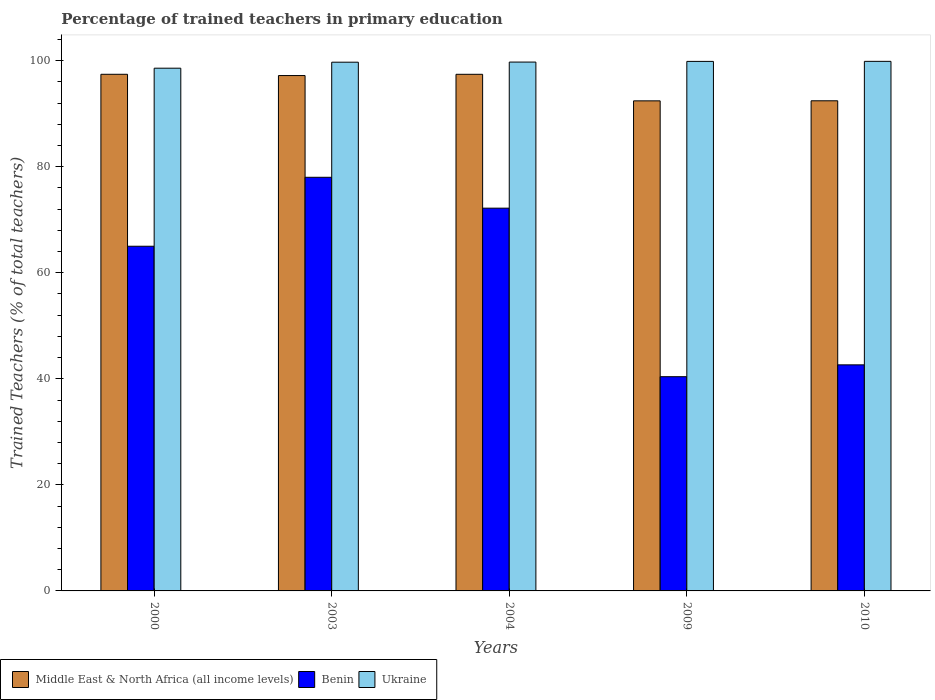How many different coloured bars are there?
Your response must be concise. 3. How many groups of bars are there?
Give a very brief answer. 5. Are the number of bars per tick equal to the number of legend labels?
Keep it short and to the point. Yes. How many bars are there on the 4th tick from the left?
Your answer should be compact. 3. In how many cases, is the number of bars for a given year not equal to the number of legend labels?
Provide a succinct answer. 0. What is the percentage of trained teachers in Middle East & North Africa (all income levels) in 2003?
Keep it short and to the point. 97.18. Across all years, what is the maximum percentage of trained teachers in Ukraine?
Give a very brief answer. 99.86. Across all years, what is the minimum percentage of trained teachers in Middle East & North Africa (all income levels)?
Offer a terse response. 92.41. In which year was the percentage of trained teachers in Benin maximum?
Provide a succinct answer. 2003. What is the total percentage of trained teachers in Ukraine in the graph?
Offer a terse response. 497.72. What is the difference between the percentage of trained teachers in Middle East & North Africa (all income levels) in 2004 and that in 2010?
Your response must be concise. 4.99. What is the difference between the percentage of trained teachers in Benin in 2010 and the percentage of trained teachers in Ukraine in 2003?
Make the answer very short. -57.07. What is the average percentage of trained teachers in Middle East & North Africa (all income levels) per year?
Provide a succinct answer. 95.37. In the year 2004, what is the difference between the percentage of trained teachers in Ukraine and percentage of trained teachers in Benin?
Your answer should be compact. 27.55. What is the ratio of the percentage of trained teachers in Ukraine in 2009 to that in 2010?
Offer a terse response. 1. Is the percentage of trained teachers in Ukraine in 2000 less than that in 2009?
Provide a succinct answer. Yes. What is the difference between the highest and the second highest percentage of trained teachers in Benin?
Make the answer very short. 5.82. What is the difference between the highest and the lowest percentage of trained teachers in Middle East & North Africa (all income levels)?
Your answer should be compact. 5.01. Is the sum of the percentage of trained teachers in Middle East & North Africa (all income levels) in 2004 and 2009 greater than the maximum percentage of trained teachers in Benin across all years?
Offer a terse response. Yes. What does the 1st bar from the left in 2003 represents?
Provide a short and direct response. Middle East & North Africa (all income levels). What does the 1st bar from the right in 2000 represents?
Provide a succinct answer. Ukraine. Are all the bars in the graph horizontal?
Provide a short and direct response. No. Are the values on the major ticks of Y-axis written in scientific E-notation?
Provide a short and direct response. No. Does the graph contain any zero values?
Provide a succinct answer. No. Where does the legend appear in the graph?
Your answer should be compact. Bottom left. How many legend labels are there?
Offer a very short reply. 3. How are the legend labels stacked?
Ensure brevity in your answer.  Horizontal. What is the title of the graph?
Your answer should be compact. Percentage of trained teachers in primary education. Does "Tuvalu" appear as one of the legend labels in the graph?
Offer a very short reply. No. What is the label or title of the Y-axis?
Offer a very short reply. Trained Teachers (% of total teachers). What is the Trained Teachers (% of total teachers) in Middle East & North Africa (all income levels) in 2000?
Offer a terse response. 97.42. What is the Trained Teachers (% of total teachers) of Benin in 2000?
Your response must be concise. 65. What is the Trained Teachers (% of total teachers) of Ukraine in 2000?
Give a very brief answer. 98.57. What is the Trained Teachers (% of total teachers) of Middle East & North Africa (all income levels) in 2003?
Provide a succinct answer. 97.18. What is the Trained Teachers (% of total teachers) of Benin in 2003?
Offer a terse response. 78. What is the Trained Teachers (% of total teachers) of Ukraine in 2003?
Offer a very short reply. 99.7. What is the Trained Teachers (% of total teachers) of Middle East & North Africa (all income levels) in 2004?
Your answer should be compact. 97.42. What is the Trained Teachers (% of total teachers) in Benin in 2004?
Make the answer very short. 72.18. What is the Trained Teachers (% of total teachers) in Ukraine in 2004?
Provide a succinct answer. 99.73. What is the Trained Teachers (% of total teachers) in Middle East & North Africa (all income levels) in 2009?
Make the answer very short. 92.41. What is the Trained Teachers (% of total teachers) in Benin in 2009?
Provide a succinct answer. 40.4. What is the Trained Teachers (% of total teachers) in Ukraine in 2009?
Keep it short and to the point. 99.86. What is the Trained Teachers (% of total teachers) in Middle East & North Africa (all income levels) in 2010?
Provide a succinct answer. 92.43. What is the Trained Teachers (% of total teachers) of Benin in 2010?
Offer a very short reply. 42.63. What is the Trained Teachers (% of total teachers) in Ukraine in 2010?
Keep it short and to the point. 99.86. Across all years, what is the maximum Trained Teachers (% of total teachers) in Middle East & North Africa (all income levels)?
Offer a very short reply. 97.42. Across all years, what is the maximum Trained Teachers (% of total teachers) in Benin?
Provide a short and direct response. 78. Across all years, what is the maximum Trained Teachers (% of total teachers) of Ukraine?
Provide a succinct answer. 99.86. Across all years, what is the minimum Trained Teachers (% of total teachers) in Middle East & North Africa (all income levels)?
Provide a succinct answer. 92.41. Across all years, what is the minimum Trained Teachers (% of total teachers) of Benin?
Your answer should be compact. 40.4. Across all years, what is the minimum Trained Teachers (% of total teachers) of Ukraine?
Your answer should be compact. 98.57. What is the total Trained Teachers (% of total teachers) of Middle East & North Africa (all income levels) in the graph?
Your answer should be compact. 476.87. What is the total Trained Teachers (% of total teachers) in Benin in the graph?
Your answer should be very brief. 298.2. What is the total Trained Teachers (% of total teachers) of Ukraine in the graph?
Your answer should be compact. 497.72. What is the difference between the Trained Teachers (% of total teachers) of Middle East & North Africa (all income levels) in 2000 and that in 2003?
Offer a terse response. 0.24. What is the difference between the Trained Teachers (% of total teachers) of Benin in 2000 and that in 2003?
Offer a terse response. -13. What is the difference between the Trained Teachers (% of total teachers) of Ukraine in 2000 and that in 2003?
Ensure brevity in your answer.  -1.13. What is the difference between the Trained Teachers (% of total teachers) of Middle East & North Africa (all income levels) in 2000 and that in 2004?
Your answer should be compact. 0. What is the difference between the Trained Teachers (% of total teachers) in Benin in 2000 and that in 2004?
Provide a succinct answer. -7.18. What is the difference between the Trained Teachers (% of total teachers) of Ukraine in 2000 and that in 2004?
Ensure brevity in your answer.  -1.15. What is the difference between the Trained Teachers (% of total teachers) of Middle East & North Africa (all income levels) in 2000 and that in 2009?
Provide a short and direct response. 5.01. What is the difference between the Trained Teachers (% of total teachers) in Benin in 2000 and that in 2009?
Offer a very short reply. 24.6. What is the difference between the Trained Teachers (% of total teachers) of Ukraine in 2000 and that in 2009?
Keep it short and to the point. -1.28. What is the difference between the Trained Teachers (% of total teachers) of Middle East & North Africa (all income levels) in 2000 and that in 2010?
Offer a terse response. 4.99. What is the difference between the Trained Teachers (% of total teachers) in Benin in 2000 and that in 2010?
Provide a short and direct response. 22.37. What is the difference between the Trained Teachers (% of total teachers) in Ukraine in 2000 and that in 2010?
Keep it short and to the point. -1.29. What is the difference between the Trained Teachers (% of total teachers) of Middle East & North Africa (all income levels) in 2003 and that in 2004?
Keep it short and to the point. -0.24. What is the difference between the Trained Teachers (% of total teachers) of Benin in 2003 and that in 2004?
Ensure brevity in your answer.  5.82. What is the difference between the Trained Teachers (% of total teachers) of Ukraine in 2003 and that in 2004?
Offer a terse response. -0.02. What is the difference between the Trained Teachers (% of total teachers) of Middle East & North Africa (all income levels) in 2003 and that in 2009?
Your response must be concise. 4.77. What is the difference between the Trained Teachers (% of total teachers) of Benin in 2003 and that in 2009?
Provide a succinct answer. 37.6. What is the difference between the Trained Teachers (% of total teachers) of Ukraine in 2003 and that in 2009?
Offer a very short reply. -0.15. What is the difference between the Trained Teachers (% of total teachers) of Middle East & North Africa (all income levels) in 2003 and that in 2010?
Your answer should be very brief. 4.76. What is the difference between the Trained Teachers (% of total teachers) in Benin in 2003 and that in 2010?
Offer a very short reply. 35.37. What is the difference between the Trained Teachers (% of total teachers) of Ukraine in 2003 and that in 2010?
Keep it short and to the point. -0.16. What is the difference between the Trained Teachers (% of total teachers) of Middle East & North Africa (all income levels) in 2004 and that in 2009?
Your answer should be very brief. 5.01. What is the difference between the Trained Teachers (% of total teachers) in Benin in 2004 and that in 2009?
Give a very brief answer. 31.78. What is the difference between the Trained Teachers (% of total teachers) of Ukraine in 2004 and that in 2009?
Keep it short and to the point. -0.13. What is the difference between the Trained Teachers (% of total teachers) of Middle East & North Africa (all income levels) in 2004 and that in 2010?
Make the answer very short. 4.99. What is the difference between the Trained Teachers (% of total teachers) in Benin in 2004 and that in 2010?
Offer a terse response. 29.55. What is the difference between the Trained Teachers (% of total teachers) in Ukraine in 2004 and that in 2010?
Make the answer very short. -0.14. What is the difference between the Trained Teachers (% of total teachers) in Middle East & North Africa (all income levels) in 2009 and that in 2010?
Ensure brevity in your answer.  -0.01. What is the difference between the Trained Teachers (% of total teachers) of Benin in 2009 and that in 2010?
Make the answer very short. -2.23. What is the difference between the Trained Teachers (% of total teachers) of Ukraine in 2009 and that in 2010?
Give a very brief answer. -0.01. What is the difference between the Trained Teachers (% of total teachers) in Middle East & North Africa (all income levels) in 2000 and the Trained Teachers (% of total teachers) in Benin in 2003?
Your answer should be very brief. 19.42. What is the difference between the Trained Teachers (% of total teachers) of Middle East & North Africa (all income levels) in 2000 and the Trained Teachers (% of total teachers) of Ukraine in 2003?
Offer a very short reply. -2.28. What is the difference between the Trained Teachers (% of total teachers) of Benin in 2000 and the Trained Teachers (% of total teachers) of Ukraine in 2003?
Give a very brief answer. -34.71. What is the difference between the Trained Teachers (% of total teachers) in Middle East & North Africa (all income levels) in 2000 and the Trained Teachers (% of total teachers) in Benin in 2004?
Your answer should be very brief. 25.25. What is the difference between the Trained Teachers (% of total teachers) in Middle East & North Africa (all income levels) in 2000 and the Trained Teachers (% of total teachers) in Ukraine in 2004?
Keep it short and to the point. -2.31. What is the difference between the Trained Teachers (% of total teachers) in Benin in 2000 and the Trained Teachers (% of total teachers) in Ukraine in 2004?
Your answer should be compact. -34.73. What is the difference between the Trained Teachers (% of total teachers) of Middle East & North Africa (all income levels) in 2000 and the Trained Teachers (% of total teachers) of Benin in 2009?
Ensure brevity in your answer.  57.02. What is the difference between the Trained Teachers (% of total teachers) of Middle East & North Africa (all income levels) in 2000 and the Trained Teachers (% of total teachers) of Ukraine in 2009?
Give a very brief answer. -2.43. What is the difference between the Trained Teachers (% of total teachers) of Benin in 2000 and the Trained Teachers (% of total teachers) of Ukraine in 2009?
Provide a short and direct response. -34.86. What is the difference between the Trained Teachers (% of total teachers) in Middle East & North Africa (all income levels) in 2000 and the Trained Teachers (% of total teachers) in Benin in 2010?
Provide a succinct answer. 54.79. What is the difference between the Trained Teachers (% of total teachers) of Middle East & North Africa (all income levels) in 2000 and the Trained Teachers (% of total teachers) of Ukraine in 2010?
Provide a succinct answer. -2.44. What is the difference between the Trained Teachers (% of total teachers) of Benin in 2000 and the Trained Teachers (% of total teachers) of Ukraine in 2010?
Ensure brevity in your answer.  -34.87. What is the difference between the Trained Teachers (% of total teachers) in Middle East & North Africa (all income levels) in 2003 and the Trained Teachers (% of total teachers) in Benin in 2004?
Ensure brevity in your answer.  25.01. What is the difference between the Trained Teachers (% of total teachers) in Middle East & North Africa (all income levels) in 2003 and the Trained Teachers (% of total teachers) in Ukraine in 2004?
Provide a succinct answer. -2.54. What is the difference between the Trained Teachers (% of total teachers) in Benin in 2003 and the Trained Teachers (% of total teachers) in Ukraine in 2004?
Make the answer very short. -21.73. What is the difference between the Trained Teachers (% of total teachers) in Middle East & North Africa (all income levels) in 2003 and the Trained Teachers (% of total teachers) in Benin in 2009?
Your answer should be compact. 56.79. What is the difference between the Trained Teachers (% of total teachers) in Middle East & North Africa (all income levels) in 2003 and the Trained Teachers (% of total teachers) in Ukraine in 2009?
Make the answer very short. -2.67. What is the difference between the Trained Teachers (% of total teachers) in Benin in 2003 and the Trained Teachers (% of total teachers) in Ukraine in 2009?
Your answer should be compact. -21.86. What is the difference between the Trained Teachers (% of total teachers) in Middle East & North Africa (all income levels) in 2003 and the Trained Teachers (% of total teachers) in Benin in 2010?
Offer a terse response. 54.55. What is the difference between the Trained Teachers (% of total teachers) of Middle East & North Africa (all income levels) in 2003 and the Trained Teachers (% of total teachers) of Ukraine in 2010?
Give a very brief answer. -2.68. What is the difference between the Trained Teachers (% of total teachers) of Benin in 2003 and the Trained Teachers (% of total teachers) of Ukraine in 2010?
Provide a succinct answer. -21.86. What is the difference between the Trained Teachers (% of total teachers) in Middle East & North Africa (all income levels) in 2004 and the Trained Teachers (% of total teachers) in Benin in 2009?
Keep it short and to the point. 57.02. What is the difference between the Trained Teachers (% of total teachers) in Middle East & North Africa (all income levels) in 2004 and the Trained Teachers (% of total teachers) in Ukraine in 2009?
Ensure brevity in your answer.  -2.44. What is the difference between the Trained Teachers (% of total teachers) of Benin in 2004 and the Trained Teachers (% of total teachers) of Ukraine in 2009?
Provide a succinct answer. -27.68. What is the difference between the Trained Teachers (% of total teachers) in Middle East & North Africa (all income levels) in 2004 and the Trained Teachers (% of total teachers) in Benin in 2010?
Provide a succinct answer. 54.79. What is the difference between the Trained Teachers (% of total teachers) of Middle East & North Africa (all income levels) in 2004 and the Trained Teachers (% of total teachers) of Ukraine in 2010?
Keep it short and to the point. -2.44. What is the difference between the Trained Teachers (% of total teachers) of Benin in 2004 and the Trained Teachers (% of total teachers) of Ukraine in 2010?
Keep it short and to the point. -27.69. What is the difference between the Trained Teachers (% of total teachers) of Middle East & North Africa (all income levels) in 2009 and the Trained Teachers (% of total teachers) of Benin in 2010?
Provide a short and direct response. 49.78. What is the difference between the Trained Teachers (% of total teachers) of Middle East & North Africa (all income levels) in 2009 and the Trained Teachers (% of total teachers) of Ukraine in 2010?
Your answer should be very brief. -7.45. What is the difference between the Trained Teachers (% of total teachers) in Benin in 2009 and the Trained Teachers (% of total teachers) in Ukraine in 2010?
Your answer should be compact. -59.46. What is the average Trained Teachers (% of total teachers) of Middle East & North Africa (all income levels) per year?
Offer a very short reply. 95.37. What is the average Trained Teachers (% of total teachers) in Benin per year?
Keep it short and to the point. 59.64. What is the average Trained Teachers (% of total teachers) of Ukraine per year?
Make the answer very short. 99.54. In the year 2000, what is the difference between the Trained Teachers (% of total teachers) of Middle East & North Africa (all income levels) and Trained Teachers (% of total teachers) of Benin?
Your answer should be compact. 32.42. In the year 2000, what is the difference between the Trained Teachers (% of total teachers) of Middle East & North Africa (all income levels) and Trained Teachers (% of total teachers) of Ukraine?
Give a very brief answer. -1.15. In the year 2000, what is the difference between the Trained Teachers (% of total teachers) of Benin and Trained Teachers (% of total teachers) of Ukraine?
Offer a very short reply. -33.58. In the year 2003, what is the difference between the Trained Teachers (% of total teachers) of Middle East & North Africa (all income levels) and Trained Teachers (% of total teachers) of Benin?
Provide a short and direct response. 19.19. In the year 2003, what is the difference between the Trained Teachers (% of total teachers) of Middle East & North Africa (all income levels) and Trained Teachers (% of total teachers) of Ukraine?
Ensure brevity in your answer.  -2.52. In the year 2003, what is the difference between the Trained Teachers (% of total teachers) of Benin and Trained Teachers (% of total teachers) of Ukraine?
Offer a terse response. -21.7. In the year 2004, what is the difference between the Trained Teachers (% of total teachers) in Middle East & North Africa (all income levels) and Trained Teachers (% of total teachers) in Benin?
Your answer should be very brief. 25.24. In the year 2004, what is the difference between the Trained Teachers (% of total teachers) in Middle East & North Africa (all income levels) and Trained Teachers (% of total teachers) in Ukraine?
Offer a terse response. -2.31. In the year 2004, what is the difference between the Trained Teachers (% of total teachers) in Benin and Trained Teachers (% of total teachers) in Ukraine?
Offer a terse response. -27.55. In the year 2009, what is the difference between the Trained Teachers (% of total teachers) in Middle East & North Africa (all income levels) and Trained Teachers (% of total teachers) in Benin?
Your response must be concise. 52.02. In the year 2009, what is the difference between the Trained Teachers (% of total teachers) of Middle East & North Africa (all income levels) and Trained Teachers (% of total teachers) of Ukraine?
Ensure brevity in your answer.  -7.44. In the year 2009, what is the difference between the Trained Teachers (% of total teachers) in Benin and Trained Teachers (% of total teachers) in Ukraine?
Your answer should be compact. -59.46. In the year 2010, what is the difference between the Trained Teachers (% of total teachers) of Middle East & North Africa (all income levels) and Trained Teachers (% of total teachers) of Benin?
Make the answer very short. 49.8. In the year 2010, what is the difference between the Trained Teachers (% of total teachers) of Middle East & North Africa (all income levels) and Trained Teachers (% of total teachers) of Ukraine?
Make the answer very short. -7.44. In the year 2010, what is the difference between the Trained Teachers (% of total teachers) of Benin and Trained Teachers (% of total teachers) of Ukraine?
Make the answer very short. -57.23. What is the ratio of the Trained Teachers (% of total teachers) in Middle East & North Africa (all income levels) in 2000 to that in 2003?
Your answer should be compact. 1. What is the ratio of the Trained Teachers (% of total teachers) of Ukraine in 2000 to that in 2003?
Your response must be concise. 0.99. What is the ratio of the Trained Teachers (% of total teachers) of Benin in 2000 to that in 2004?
Give a very brief answer. 0.9. What is the ratio of the Trained Teachers (% of total teachers) in Ukraine in 2000 to that in 2004?
Give a very brief answer. 0.99. What is the ratio of the Trained Teachers (% of total teachers) in Middle East & North Africa (all income levels) in 2000 to that in 2009?
Provide a short and direct response. 1.05. What is the ratio of the Trained Teachers (% of total teachers) of Benin in 2000 to that in 2009?
Your answer should be very brief. 1.61. What is the ratio of the Trained Teachers (% of total teachers) in Ukraine in 2000 to that in 2009?
Offer a terse response. 0.99. What is the ratio of the Trained Teachers (% of total teachers) of Middle East & North Africa (all income levels) in 2000 to that in 2010?
Ensure brevity in your answer.  1.05. What is the ratio of the Trained Teachers (% of total teachers) of Benin in 2000 to that in 2010?
Your response must be concise. 1.52. What is the ratio of the Trained Teachers (% of total teachers) of Ukraine in 2000 to that in 2010?
Keep it short and to the point. 0.99. What is the ratio of the Trained Teachers (% of total teachers) in Benin in 2003 to that in 2004?
Your answer should be very brief. 1.08. What is the ratio of the Trained Teachers (% of total teachers) of Middle East & North Africa (all income levels) in 2003 to that in 2009?
Offer a very short reply. 1.05. What is the ratio of the Trained Teachers (% of total teachers) in Benin in 2003 to that in 2009?
Provide a short and direct response. 1.93. What is the ratio of the Trained Teachers (% of total teachers) in Ukraine in 2003 to that in 2009?
Offer a terse response. 1. What is the ratio of the Trained Teachers (% of total teachers) in Middle East & North Africa (all income levels) in 2003 to that in 2010?
Offer a terse response. 1.05. What is the ratio of the Trained Teachers (% of total teachers) in Benin in 2003 to that in 2010?
Your response must be concise. 1.83. What is the ratio of the Trained Teachers (% of total teachers) of Middle East & North Africa (all income levels) in 2004 to that in 2009?
Provide a short and direct response. 1.05. What is the ratio of the Trained Teachers (% of total teachers) in Benin in 2004 to that in 2009?
Your response must be concise. 1.79. What is the ratio of the Trained Teachers (% of total teachers) of Ukraine in 2004 to that in 2009?
Your answer should be very brief. 1. What is the ratio of the Trained Teachers (% of total teachers) in Middle East & North Africa (all income levels) in 2004 to that in 2010?
Your answer should be very brief. 1.05. What is the ratio of the Trained Teachers (% of total teachers) of Benin in 2004 to that in 2010?
Keep it short and to the point. 1.69. What is the ratio of the Trained Teachers (% of total teachers) of Benin in 2009 to that in 2010?
Provide a succinct answer. 0.95. What is the difference between the highest and the second highest Trained Teachers (% of total teachers) in Middle East & North Africa (all income levels)?
Your answer should be very brief. 0. What is the difference between the highest and the second highest Trained Teachers (% of total teachers) of Benin?
Your response must be concise. 5.82. What is the difference between the highest and the second highest Trained Teachers (% of total teachers) of Ukraine?
Offer a very short reply. 0.01. What is the difference between the highest and the lowest Trained Teachers (% of total teachers) in Middle East & North Africa (all income levels)?
Make the answer very short. 5.01. What is the difference between the highest and the lowest Trained Teachers (% of total teachers) in Benin?
Provide a short and direct response. 37.6. What is the difference between the highest and the lowest Trained Teachers (% of total teachers) of Ukraine?
Your answer should be compact. 1.29. 